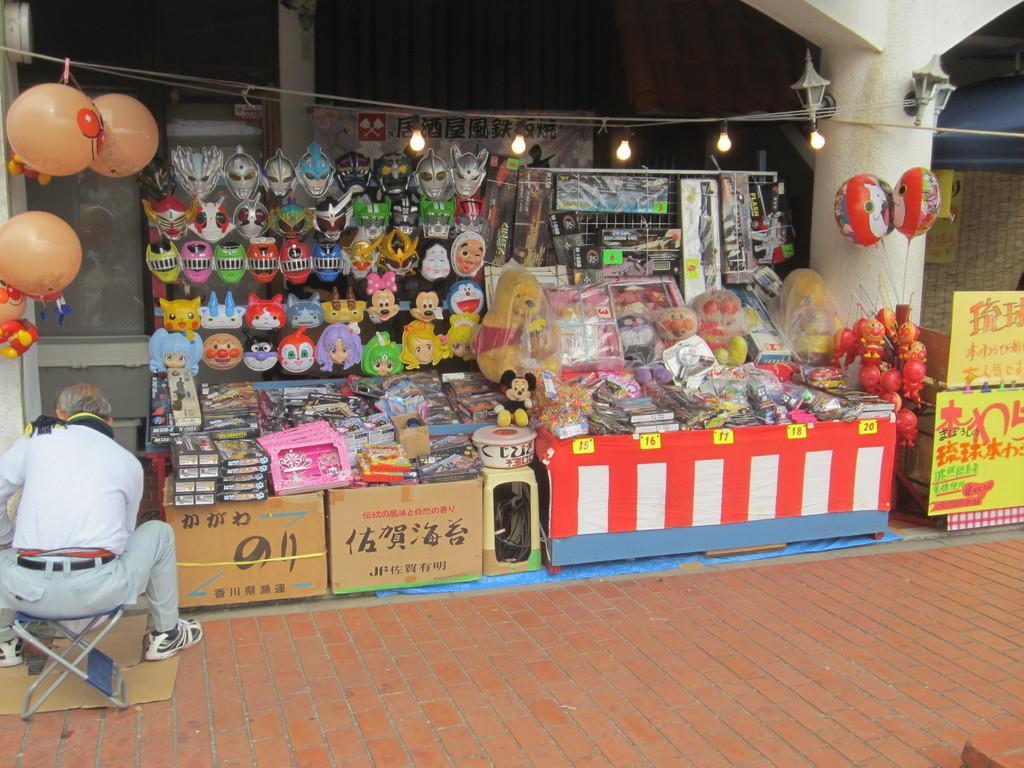How would you summarize this image in a sentence or two? In this image in the center there are some boxes and toys, on the left side there is one person who is sitting on a stool. And there are some balloons, in the center there is a rope and lights and in the background there is a house and a pillar. At the bottom there is a floor. 